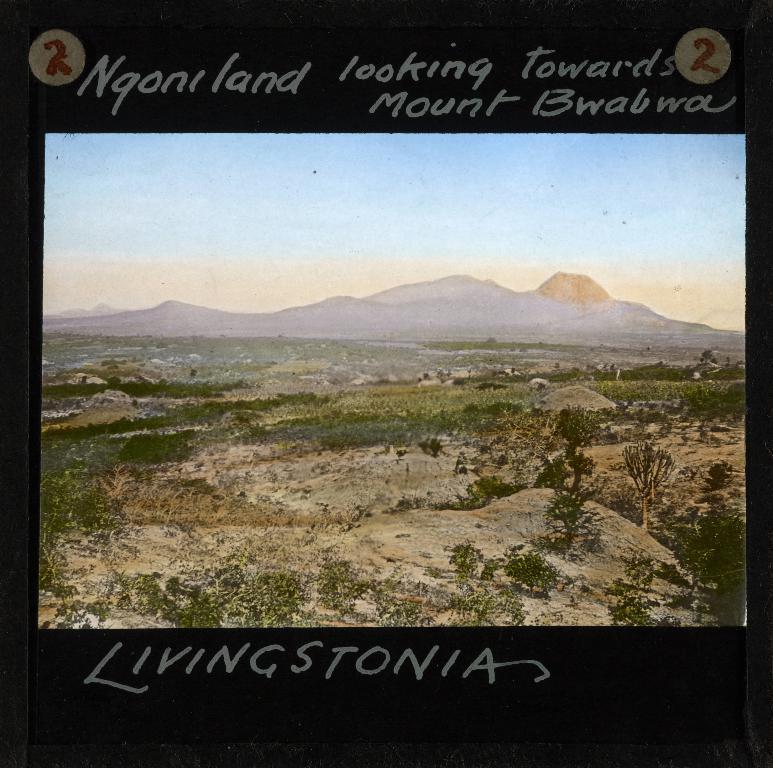What is the name of this mountain?
Your answer should be very brief. Mount bwabwa. Whsat number is in the circles at the top?
Provide a succinct answer. 2. 